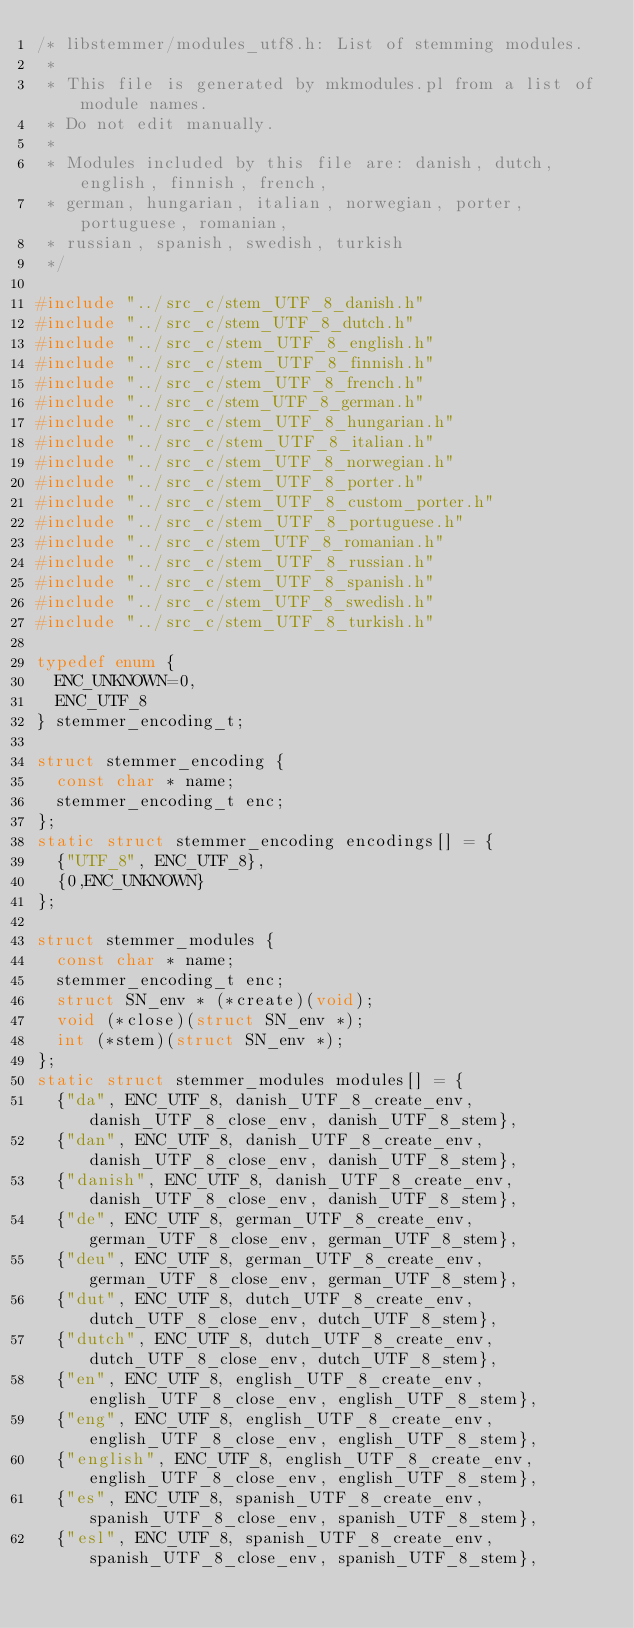Convert code to text. <code><loc_0><loc_0><loc_500><loc_500><_C_>/* libstemmer/modules_utf8.h: List of stemming modules.
 *
 * This file is generated by mkmodules.pl from a list of module names.
 * Do not edit manually.
 *
 * Modules included by this file are: danish, dutch, english, finnish, french,
 * german, hungarian, italian, norwegian, porter, portuguese, romanian,
 * russian, spanish, swedish, turkish
 */

#include "../src_c/stem_UTF_8_danish.h"
#include "../src_c/stem_UTF_8_dutch.h"
#include "../src_c/stem_UTF_8_english.h"
#include "../src_c/stem_UTF_8_finnish.h"
#include "../src_c/stem_UTF_8_french.h"
#include "../src_c/stem_UTF_8_german.h"
#include "../src_c/stem_UTF_8_hungarian.h"
#include "../src_c/stem_UTF_8_italian.h"
#include "../src_c/stem_UTF_8_norwegian.h"
#include "../src_c/stem_UTF_8_porter.h"
#include "../src_c/stem_UTF_8_custom_porter.h"
#include "../src_c/stem_UTF_8_portuguese.h"
#include "../src_c/stem_UTF_8_romanian.h"
#include "../src_c/stem_UTF_8_russian.h"
#include "../src_c/stem_UTF_8_spanish.h"
#include "../src_c/stem_UTF_8_swedish.h"
#include "../src_c/stem_UTF_8_turkish.h"

typedef enum {
  ENC_UNKNOWN=0,
  ENC_UTF_8
} stemmer_encoding_t;

struct stemmer_encoding {
  const char * name;
  stemmer_encoding_t enc;
};
static struct stemmer_encoding encodings[] = {
  {"UTF_8", ENC_UTF_8},
  {0,ENC_UNKNOWN}
};

struct stemmer_modules {
  const char * name;
  stemmer_encoding_t enc; 
  struct SN_env * (*create)(void);
  void (*close)(struct SN_env *);
  int (*stem)(struct SN_env *);
};
static struct stemmer_modules modules[] = {
  {"da", ENC_UTF_8, danish_UTF_8_create_env, danish_UTF_8_close_env, danish_UTF_8_stem},
  {"dan", ENC_UTF_8, danish_UTF_8_create_env, danish_UTF_8_close_env, danish_UTF_8_stem},
  {"danish", ENC_UTF_8, danish_UTF_8_create_env, danish_UTF_8_close_env, danish_UTF_8_stem},
  {"de", ENC_UTF_8, german_UTF_8_create_env, german_UTF_8_close_env, german_UTF_8_stem},
  {"deu", ENC_UTF_8, german_UTF_8_create_env, german_UTF_8_close_env, german_UTF_8_stem},
  {"dut", ENC_UTF_8, dutch_UTF_8_create_env, dutch_UTF_8_close_env, dutch_UTF_8_stem},
  {"dutch", ENC_UTF_8, dutch_UTF_8_create_env, dutch_UTF_8_close_env, dutch_UTF_8_stem},
  {"en", ENC_UTF_8, english_UTF_8_create_env, english_UTF_8_close_env, english_UTF_8_stem},
  {"eng", ENC_UTF_8, english_UTF_8_create_env, english_UTF_8_close_env, english_UTF_8_stem},
  {"english", ENC_UTF_8, english_UTF_8_create_env, english_UTF_8_close_env, english_UTF_8_stem},
  {"es", ENC_UTF_8, spanish_UTF_8_create_env, spanish_UTF_8_close_env, spanish_UTF_8_stem},
  {"esl", ENC_UTF_8, spanish_UTF_8_create_env, spanish_UTF_8_close_env, spanish_UTF_8_stem},</code> 